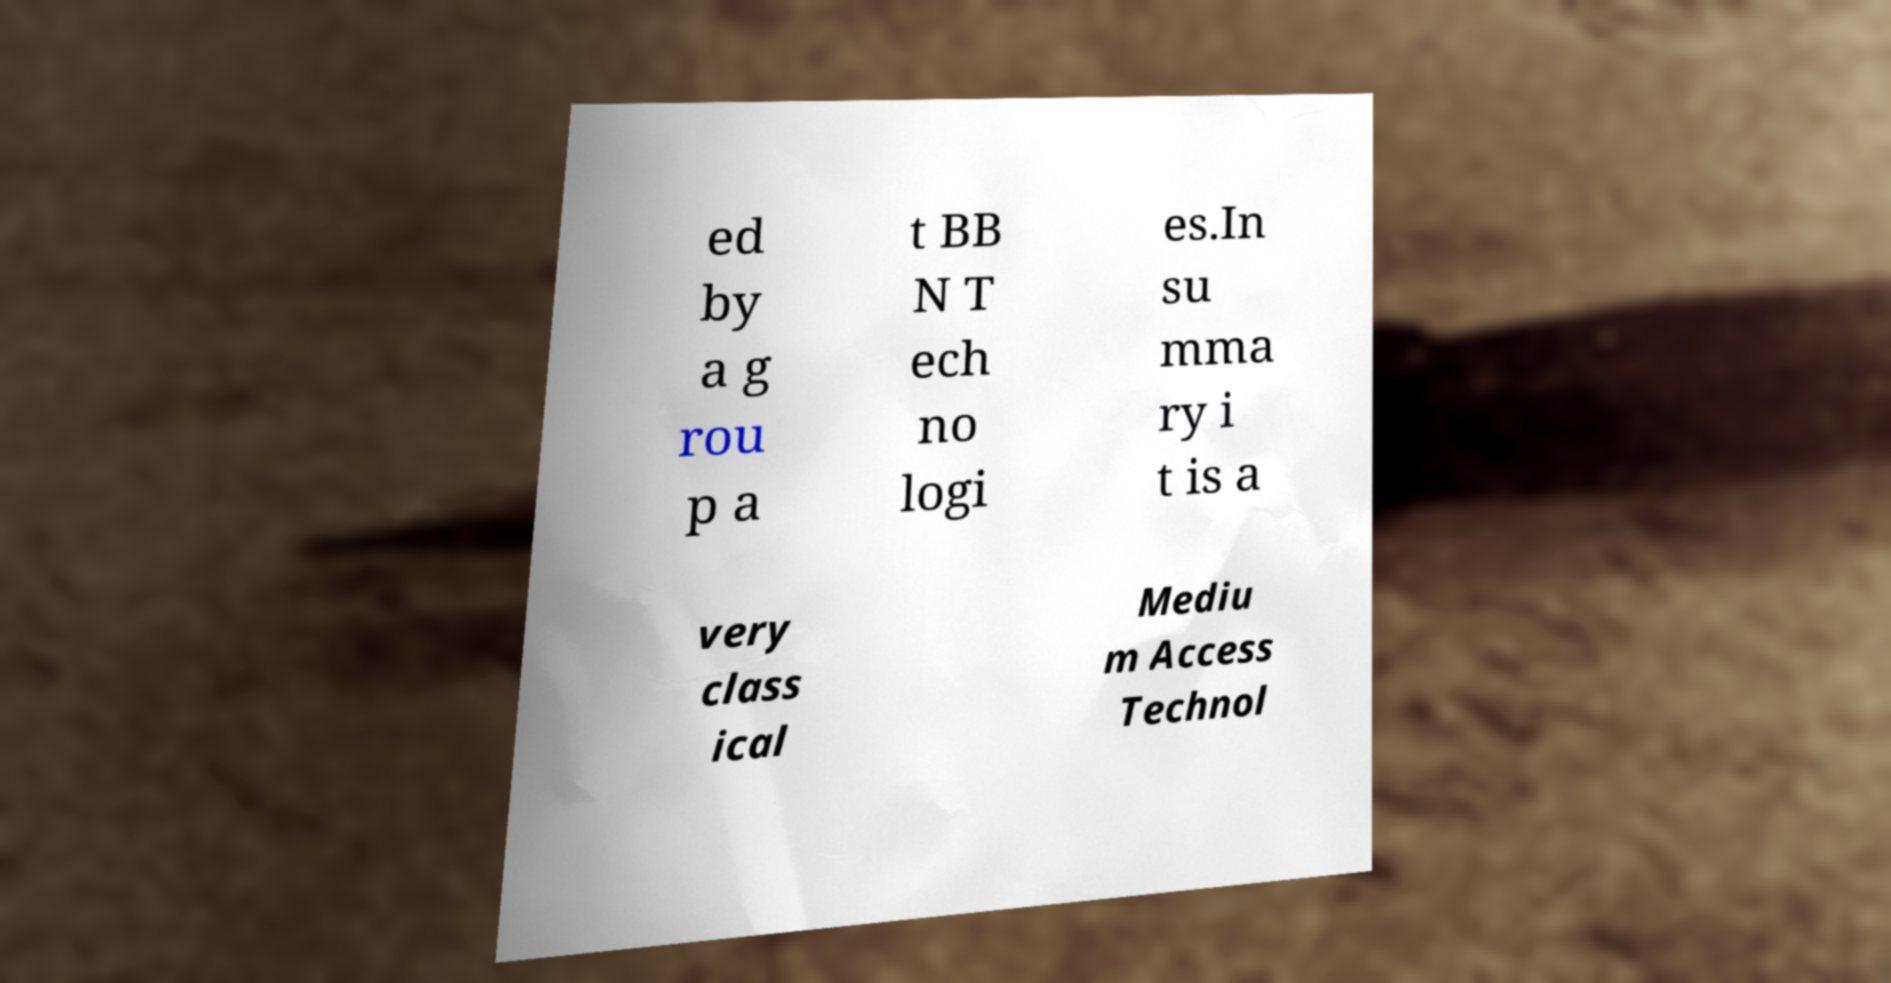For documentation purposes, I need the text within this image transcribed. Could you provide that? ed by a g rou p a t BB N T ech no logi es.In su mma ry i t is a very class ical Mediu m Access Technol 